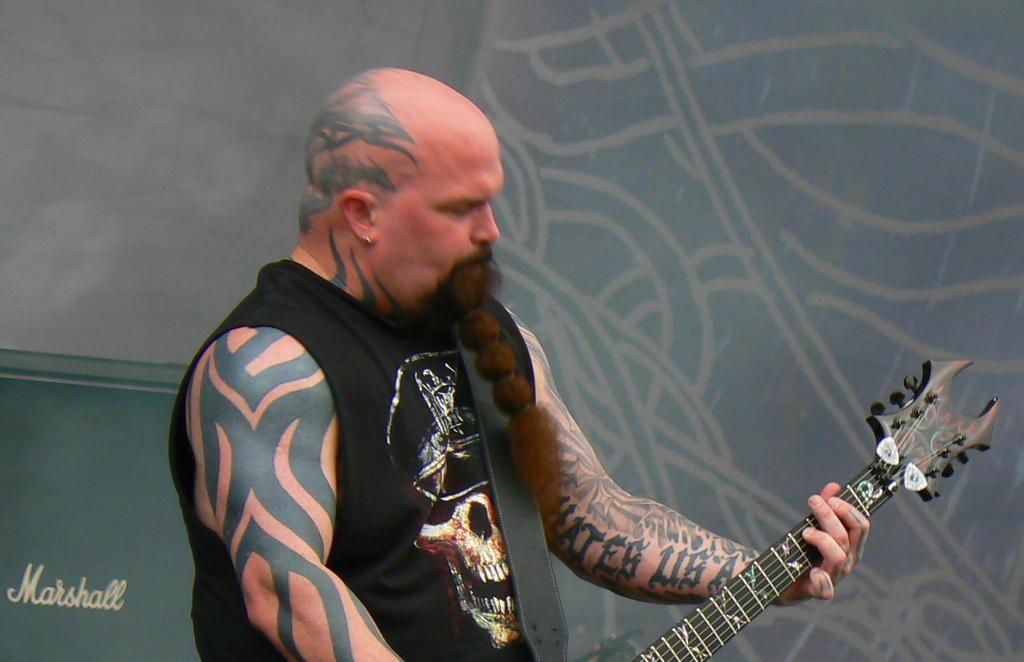Could you give a brief overview of what you see in this image? In this image we can see a man is standing and holding the guitar in his hands, and here are the tattoos on his body. 